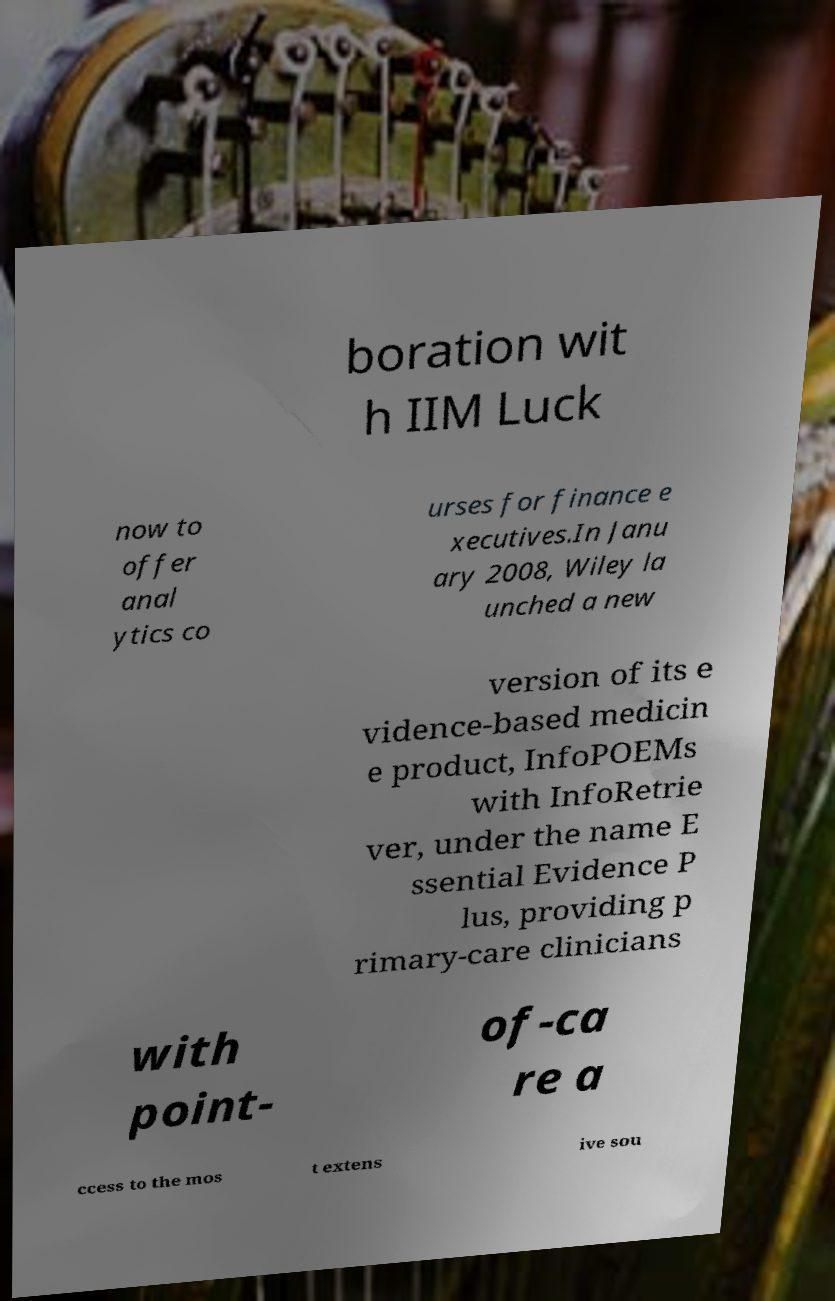For documentation purposes, I need the text within this image transcribed. Could you provide that? boration wit h IIM Luck now to offer anal ytics co urses for finance e xecutives.In Janu ary 2008, Wiley la unched a new version of its e vidence-based medicin e product, InfoPOEMs with InfoRetrie ver, under the name E ssential Evidence P lus, providing p rimary-care clinicians with point- of-ca re a ccess to the mos t extens ive sou 